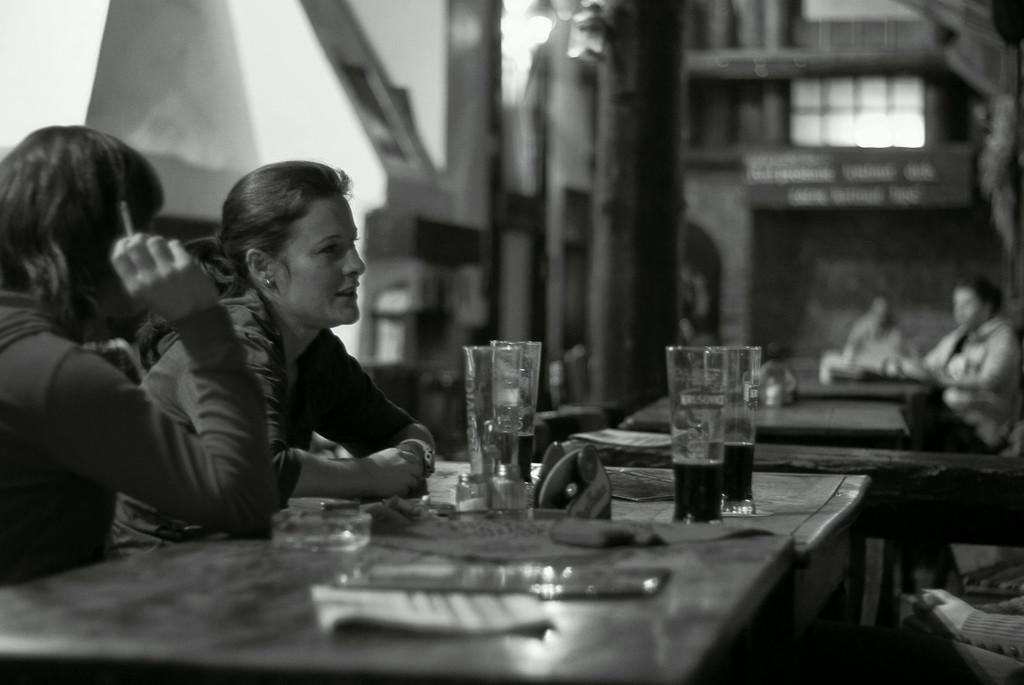How would you summarize this image in a sentence or two? In this picture we can find a two women sitting at the table, one of them is speaking and looking at the person in their front, another woman is holding a cigar in her right hand. On the table there are some objects, also there are some wine glasses present. 